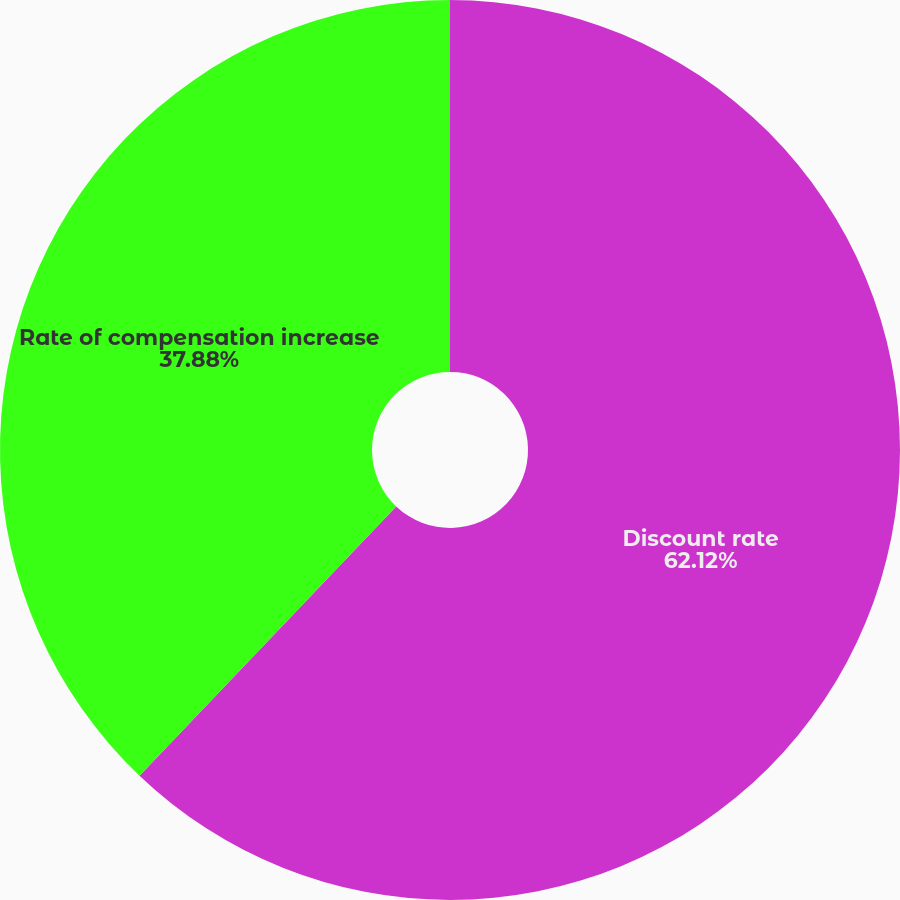Convert chart. <chart><loc_0><loc_0><loc_500><loc_500><pie_chart><fcel>Discount rate<fcel>Rate of compensation increase<nl><fcel>62.12%<fcel>37.88%<nl></chart> 